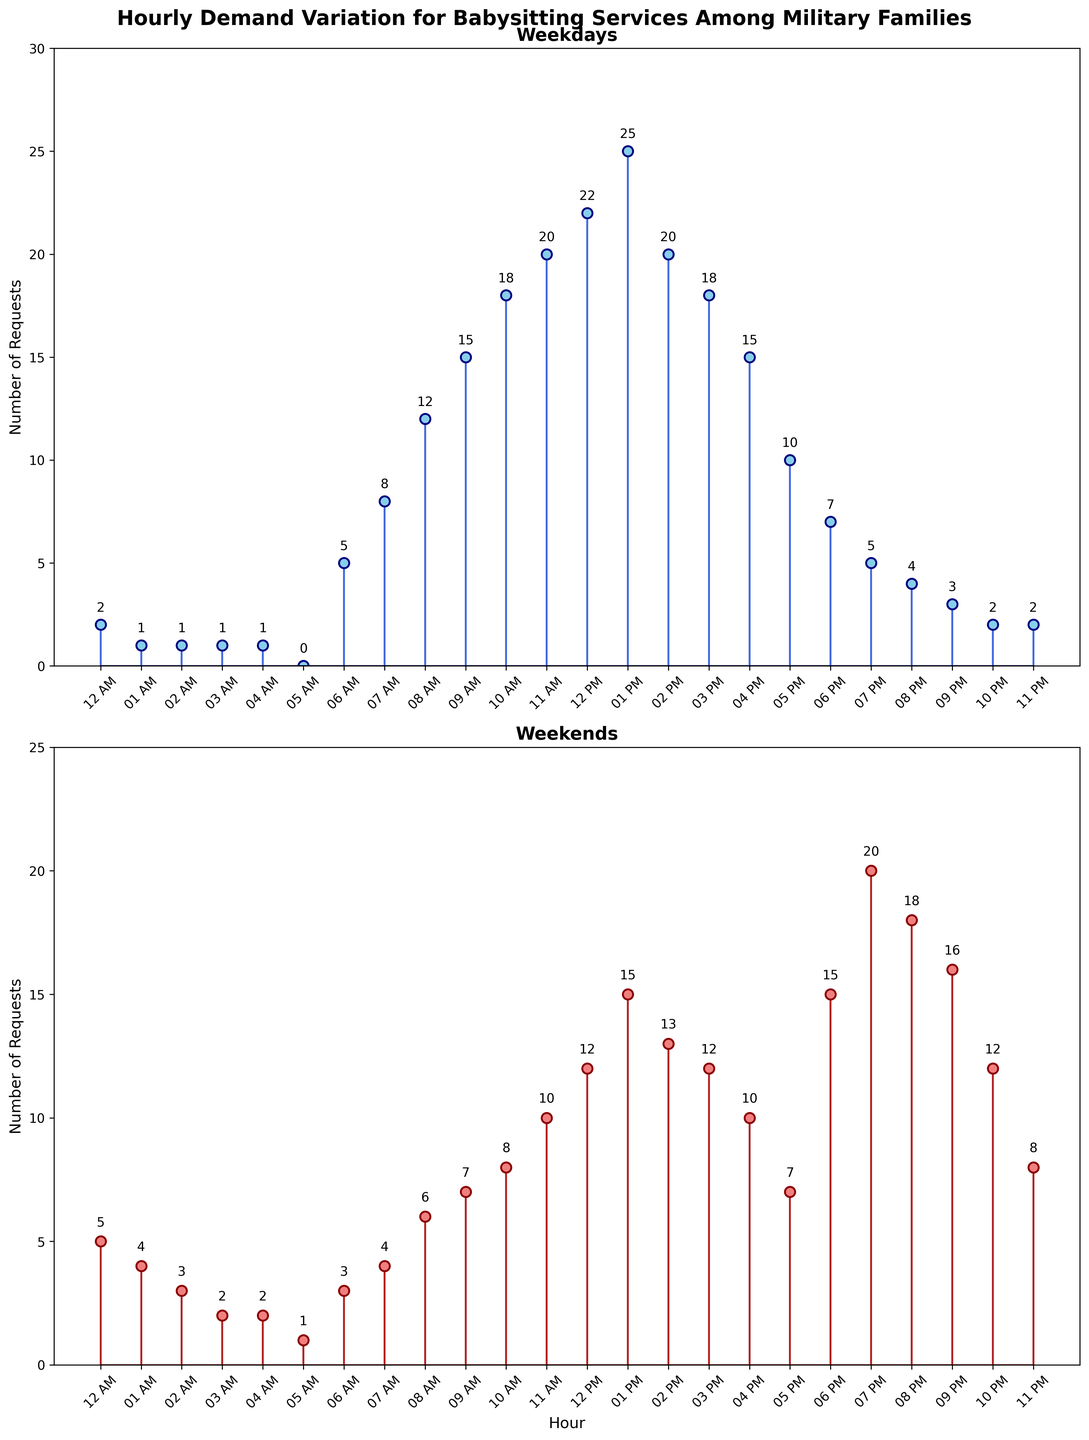What is the highest number of requests on weekdays? On the weekdays subplot, the highest vertical stem ends at the value 25 at 1 PM (13:00).
Answer: 25 During which hour are the babysitting requests on weekends the highest? On the weekends subplot, the highest stem reaches the value 20 at 7 PM (19:00).
Answer: 7 PM (19:00) What's the average number of requests at 11 AM over weekends and weekdays? At 11 AM, there are 10 requests on weekends and 20 on weekdays. The average is (10 + 20) / 2 = 15.
Answer: 15 How many hours have fewer than 5 requests on weekdays? By inspecting the weekday subplot, we see that there are five hours with fewer than 5 requests (12 AM, 1 AM, 2 AM, 3 AM, 4 AM, 5 AM, 10 PM, 11 PM).
Answer: 8 Which period sees more babysitting requests on weekends, morning (6 AM - 11:59 AM) or evening (6 PM - 11:59 PM)? Summing the values for weekends: Morning (3+4+6+7+8+10+12) gives 50, Evening (15+20+18+16+12+8) gives 89. Evening has more requests.
Answer: Evening What's the difference in the number of requests between 1 PM and 6 PM on weekdays? At 1 PM, there are 25 requests, and at 6 PM there are 7 requests on weekdays. The difference is 25 - 7 = 18.
Answer: 18 At what time is the demand for babysitting services exactly equal on both weekdays and weekends? By inspecting both subplots, at 6 AM, both have a request count of 5, respectively.
Answer: 6 AM At which hour do weekends have the lowest number of requests? The lowest stem on the weekends subplot is at 5 AM, with only 1 request.
Answer: 5 AM Which hour has the highest increase in requests from weekdays to weekends? By comparing the differences, from 4 requests on weekdays and 20 requests on weekends at 7 PM (19:00), this makes an increase of 15.
Answer: 7 PM (19:00) 